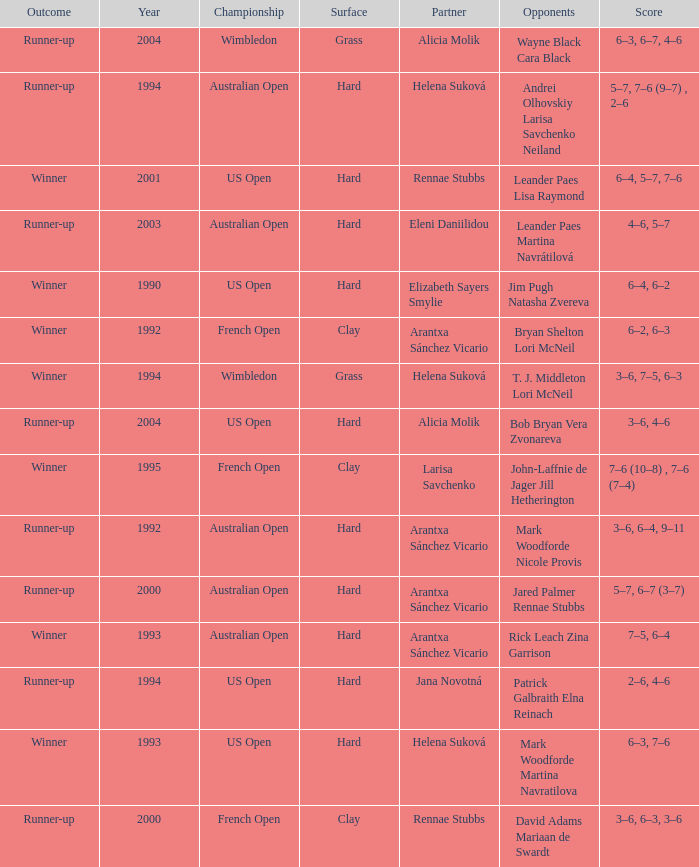Which Score has smaller than 1994, and a Partner of elizabeth sayers smylie? 6–4, 6–2. 